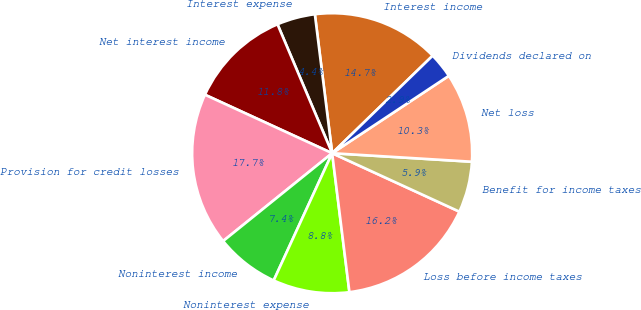Convert chart to OTSL. <chart><loc_0><loc_0><loc_500><loc_500><pie_chart><fcel>Interest income<fcel>Interest expense<fcel>Net interest income<fcel>Provision for credit losses<fcel>Noninterest income<fcel>Noninterest expense<fcel>Loss before income taxes<fcel>Benefit for income taxes<fcel>Net loss<fcel>Dividends declared on<nl><fcel>14.71%<fcel>4.41%<fcel>11.76%<fcel>17.65%<fcel>7.35%<fcel>8.82%<fcel>16.18%<fcel>5.88%<fcel>10.29%<fcel>2.94%<nl></chart> 